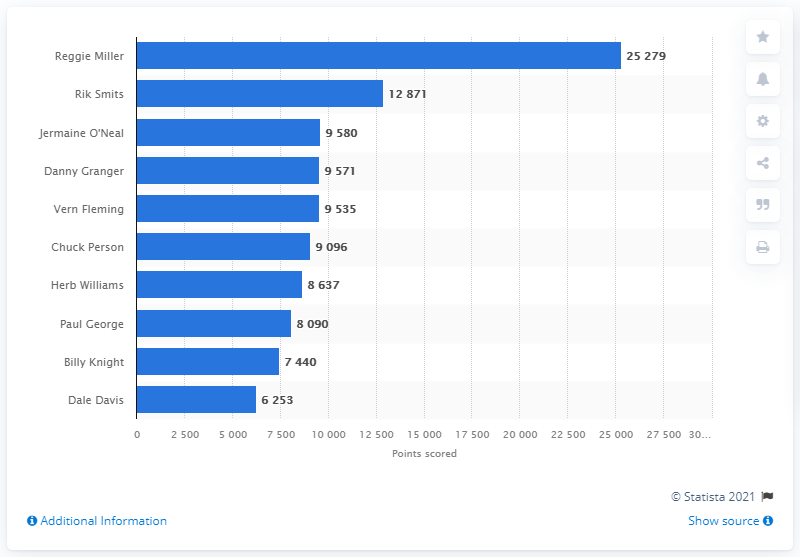Specify some key components in this picture. Reggie Miller is the career points leader of the Indiana Pacers. 